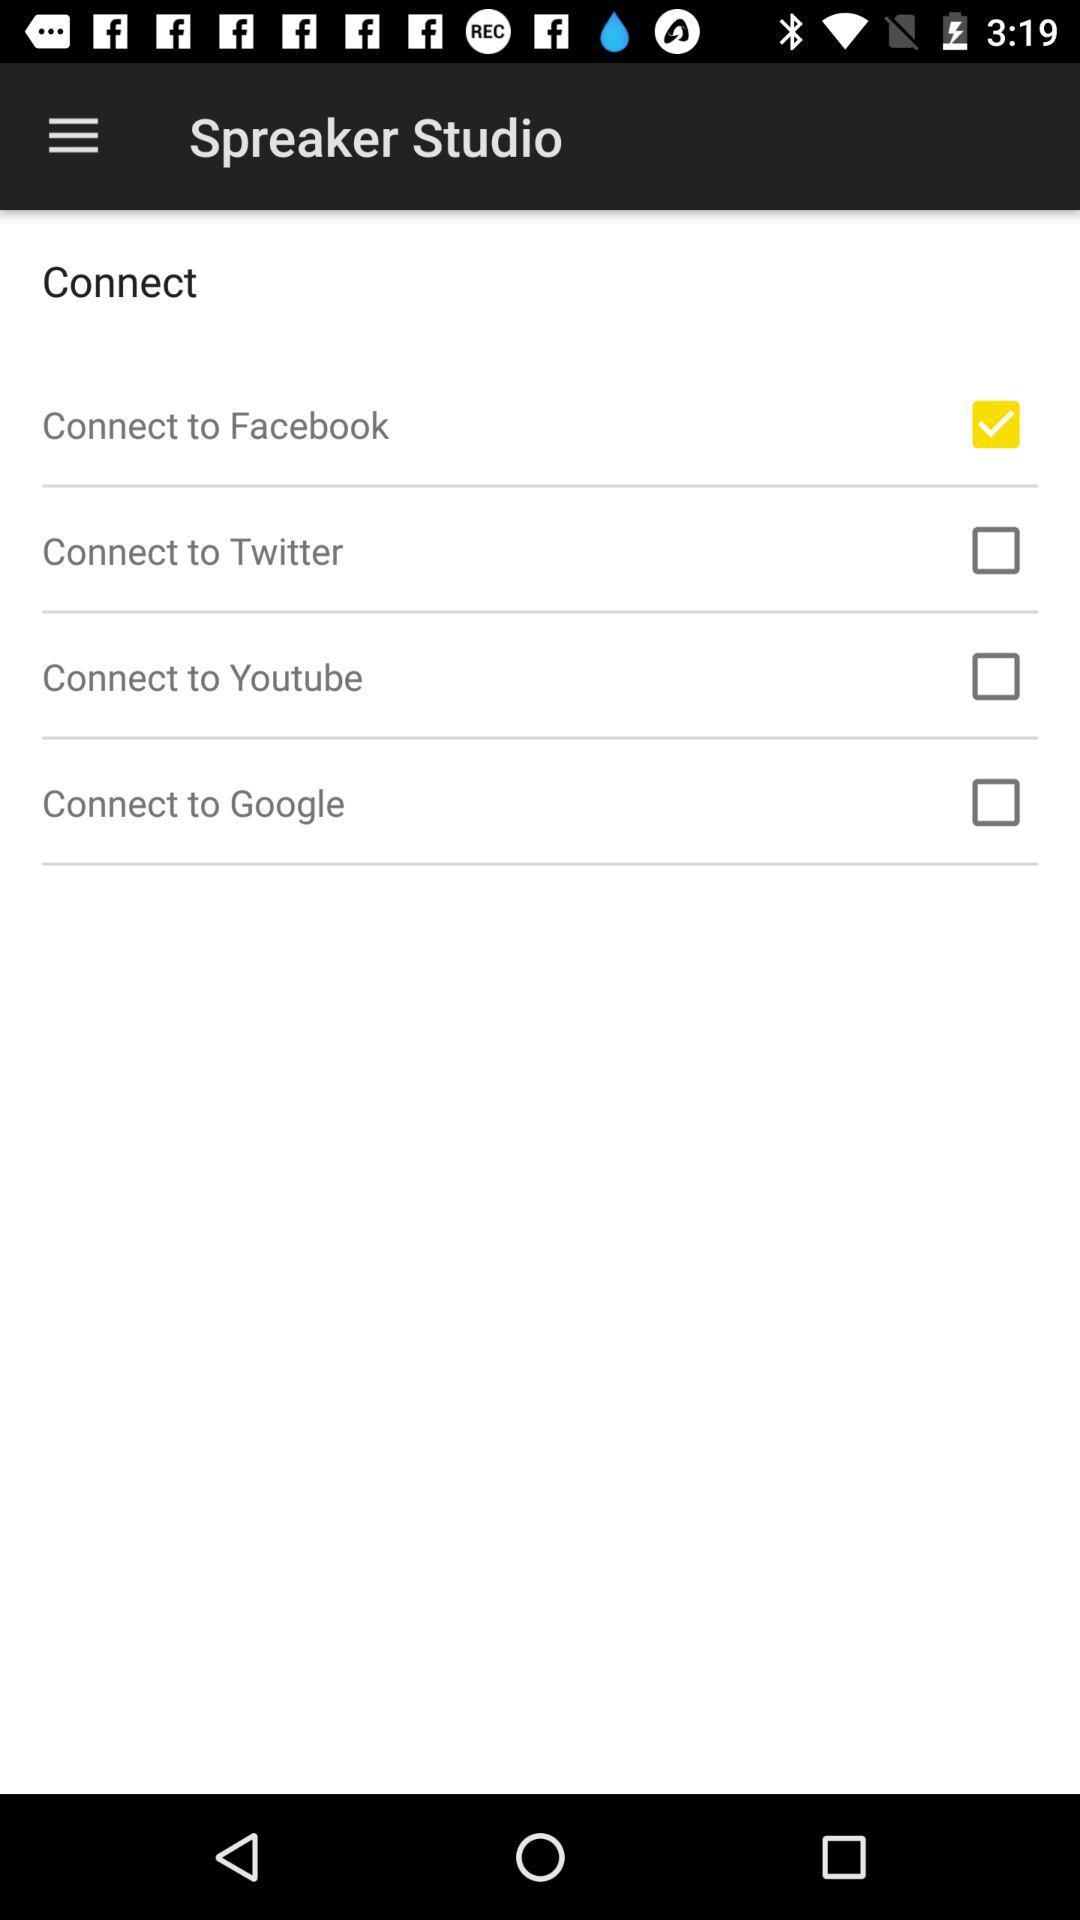How many social media platforms are available to connect to?
Answer the question using a single word or phrase. 4 